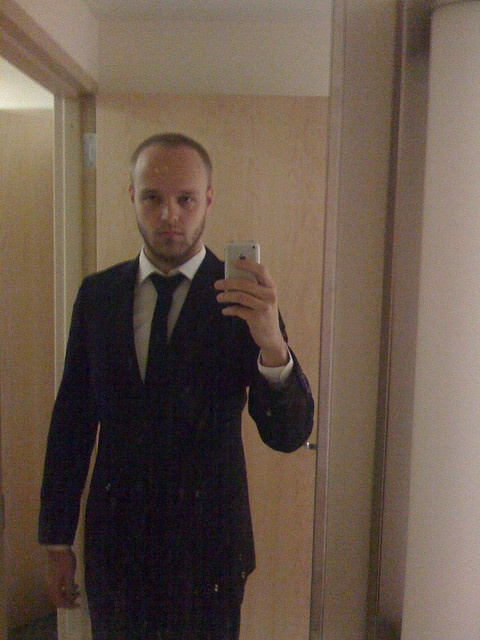Describe the objects in this image and their specific colors. I can see people in olive, black, maroon, and gray tones, tie in olive, black, navy, and darkgreen tones, cell phone in olive, gray, and darkgray tones, and cell phone in black and olive tones in this image. 